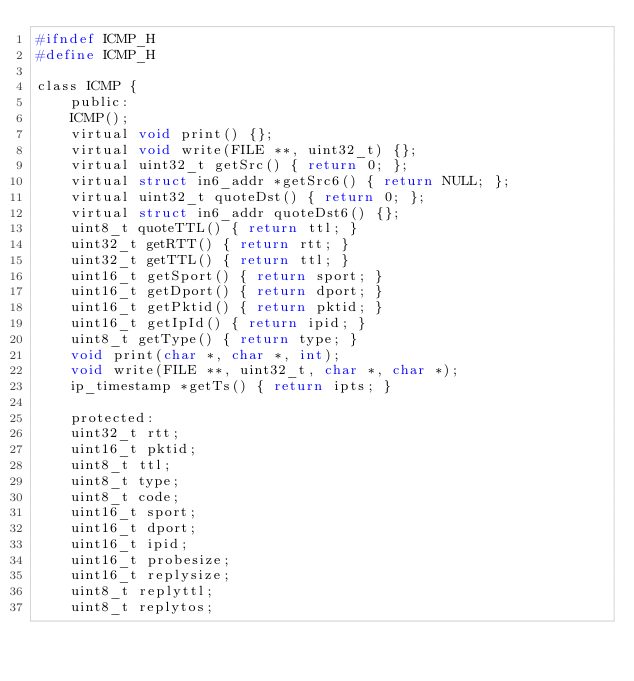<code> <loc_0><loc_0><loc_500><loc_500><_C_>#ifndef ICMP_H
#define ICMP_H

class ICMP {
    public:
    ICMP();
    virtual void print() {};
    virtual void write(FILE **, uint32_t) {};
    virtual uint32_t getSrc() { return 0; };
    virtual struct in6_addr *getSrc6() { return NULL; };
    virtual uint32_t quoteDst() { return 0; };
    virtual struct in6_addr quoteDst6() {};
    uint8_t quoteTTL() { return ttl; }
    uint32_t getRTT() { return rtt; }
    uint32_t getTTL() { return ttl; }
    uint16_t getSport() { return sport; }
    uint16_t getDport() { return dport; }
    uint16_t getPktid() { return pktid; }
    uint16_t getIpId() { return ipid; }
    uint8_t getType() { return type; }
    void print(char *, char *, int);
    void write(FILE **, uint32_t, char *, char *);
    ip_timestamp *getTs() { return ipts; }

    protected:
    uint32_t rtt;
    uint16_t pktid;
    uint8_t ttl;
    uint8_t type;
    uint8_t code;
    uint16_t sport;
    uint16_t dport;
    uint16_t ipid;
    uint16_t probesize;
    uint16_t replysize;
    uint8_t replyttl;
    uint8_t replytos;</code> 